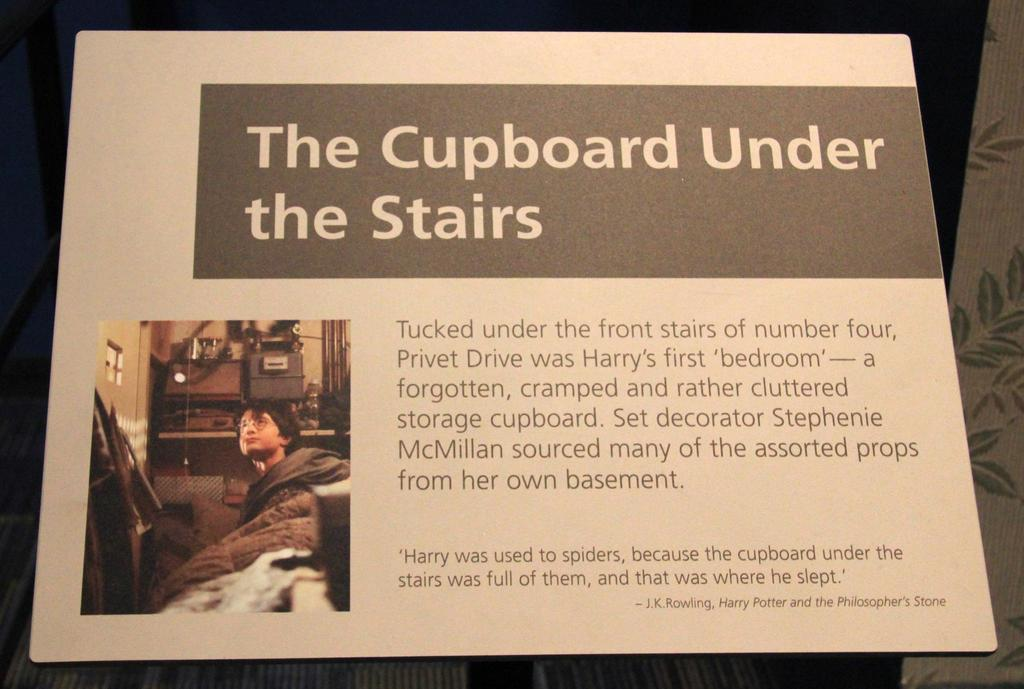<image>
Create a compact narrative representing the image presented. A slide show page with the text the cupboard under the stairs with a picture of harry potter on the bottom left. 